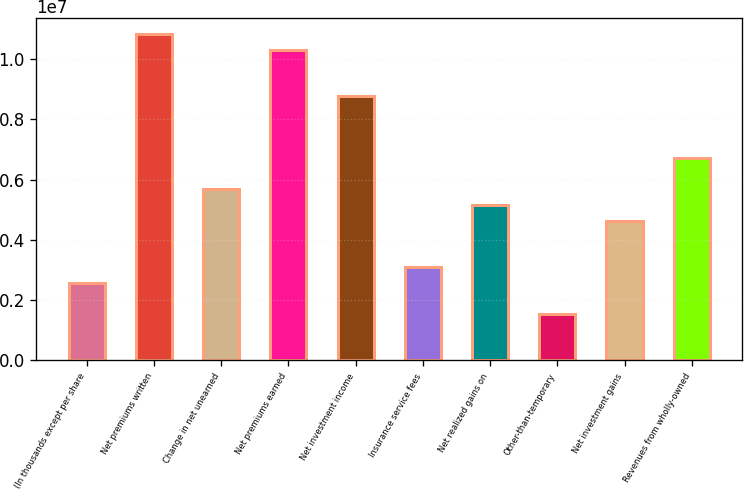Convert chart. <chart><loc_0><loc_0><loc_500><loc_500><bar_chart><fcel>(In thousands except per share<fcel>Net premiums written<fcel>Change in net unearned<fcel>Net premiums earned<fcel>Net investment income<fcel>Insurance service fees<fcel>Net realized gains on<fcel>Other-than-temporary<fcel>Net investment gains<fcel>Revenues from wholly-owned<nl><fcel>2.57799e+06<fcel>1.08276e+07<fcel>5.67158e+06<fcel>1.0312e+07<fcel>8.76517e+06<fcel>3.09359e+06<fcel>5.15598e+06<fcel>1.5468e+06<fcel>4.64039e+06<fcel>6.70278e+06<nl></chart> 